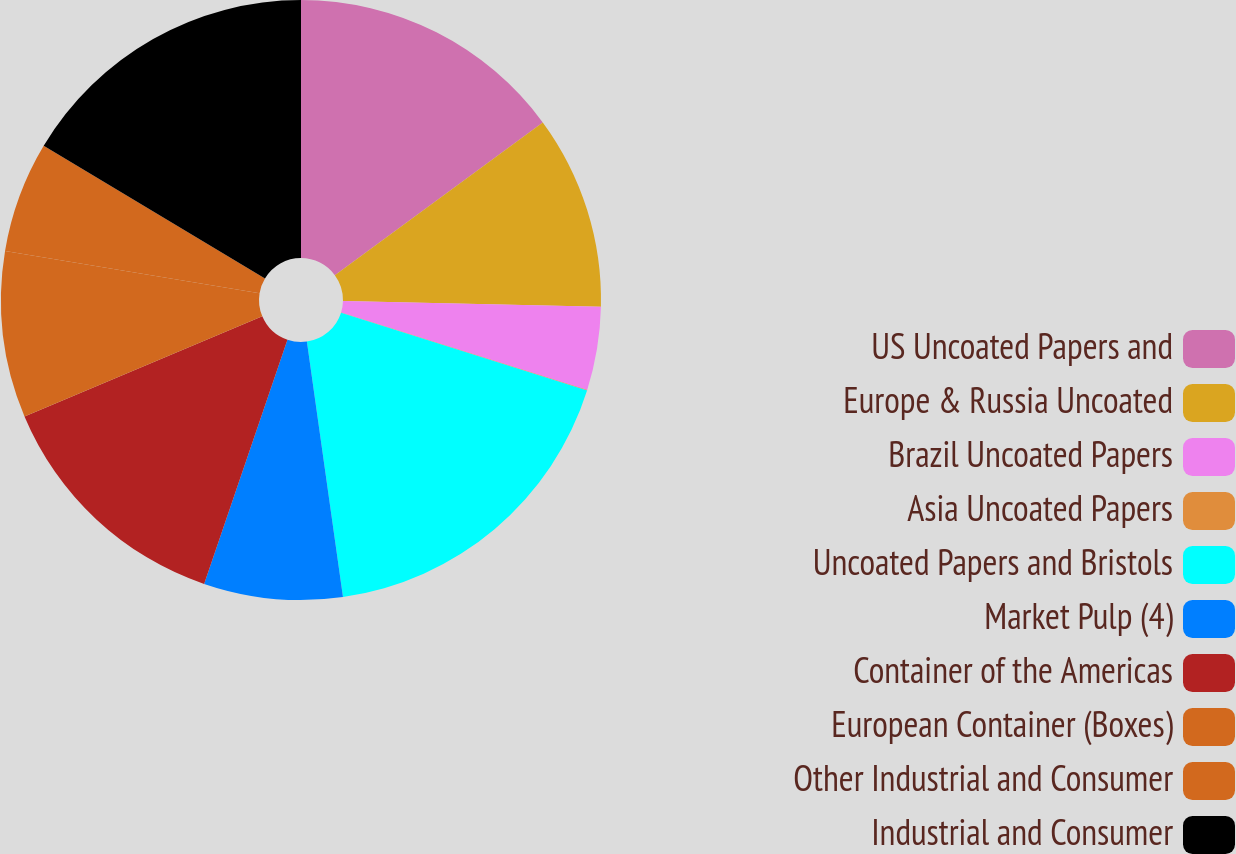Convert chart to OTSL. <chart><loc_0><loc_0><loc_500><loc_500><pie_chart><fcel>US Uncoated Papers and<fcel>Europe & Russia Uncoated<fcel>Brazil Uncoated Papers<fcel>Asia Uncoated Papers<fcel>Uncoated Papers and Bristols<fcel>Market Pulp (4)<fcel>Container of the Americas<fcel>European Container (Boxes)<fcel>Other Industrial and Consumer<fcel>Industrial and Consumer<nl><fcel>14.92%<fcel>10.45%<fcel>4.49%<fcel>0.02%<fcel>17.9%<fcel>7.47%<fcel>13.43%<fcel>8.96%<fcel>5.98%<fcel>16.41%<nl></chart> 